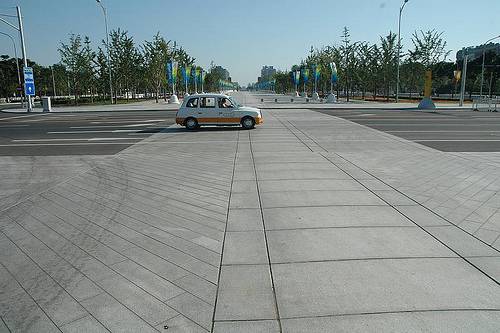<image>
Is there a car to the left of the tree? No. The car is not to the left of the tree. From this viewpoint, they have a different horizontal relationship. 